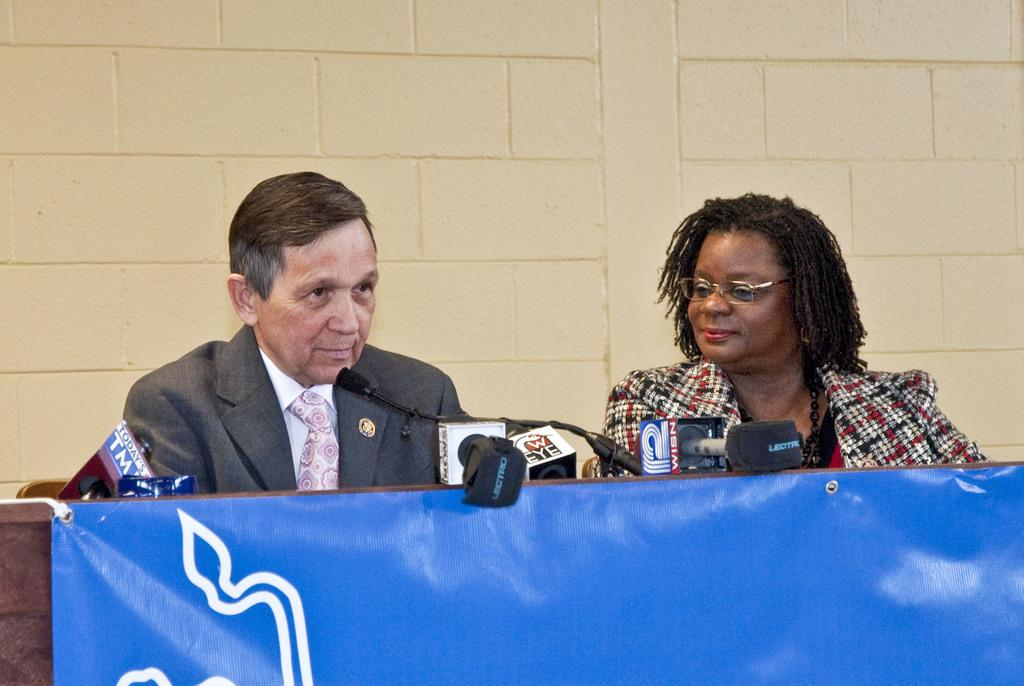How many people are present in the image? There are two persons in the image. What is the main object in the image? There is a table in the image. What is attached to the table? A poster is attached to the table. What items are on the table? There are microphones on the table. What can be seen in the background of the image? There is a wall visible in the background of the image. What type of linen is draped over the microphones in the image? There is no linen draped over the microphones in the image. How many nuts are visible on the table in the image? There are no nuts visible on the table in the image. 